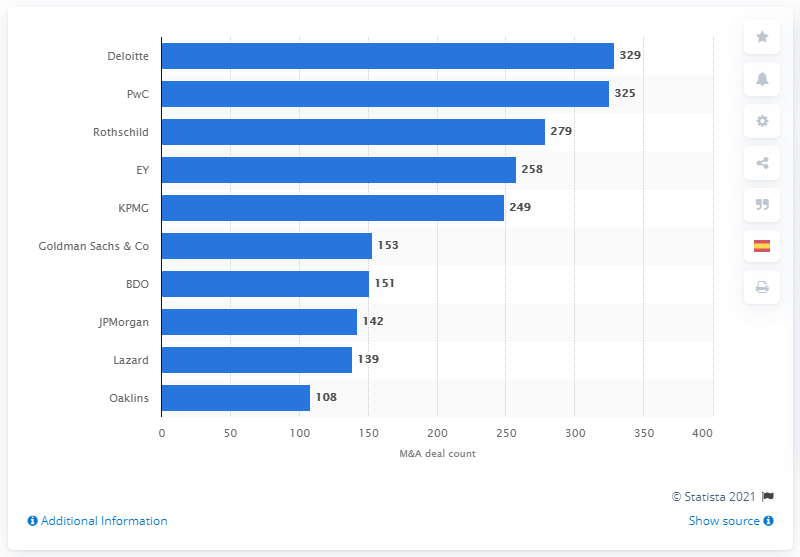List a handful of essential elements in this visual. Deloitte had 329 deals in 2018. Deloitte was the leading advisor to M&A deals in Europe in 2018. 